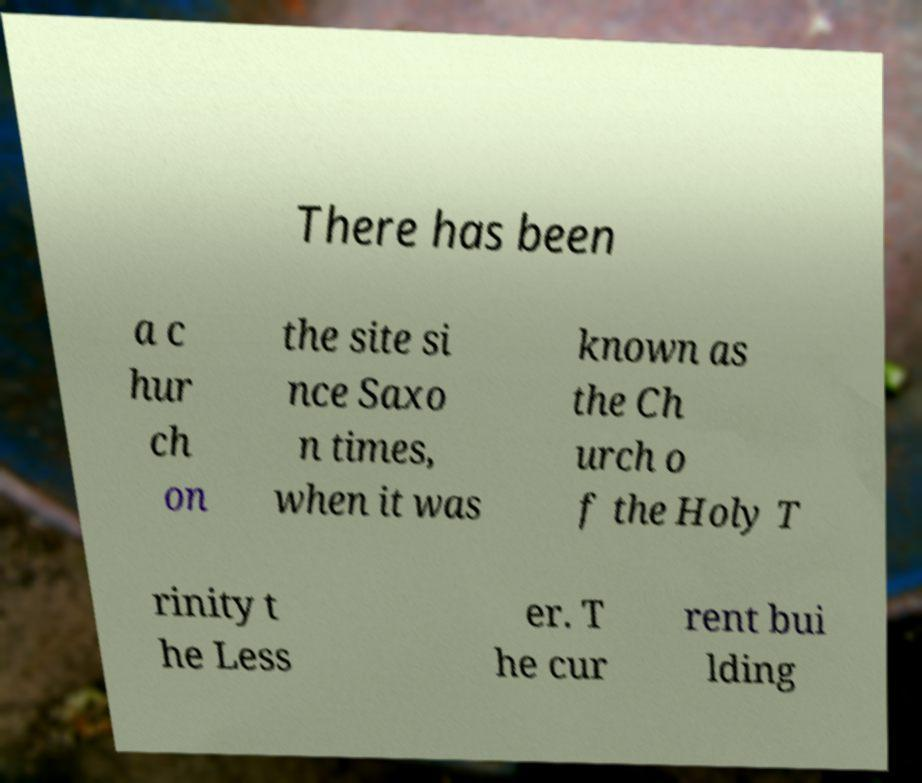Can you accurately transcribe the text from the provided image for me? There has been a c hur ch on the site si nce Saxo n times, when it was known as the Ch urch o f the Holy T rinity t he Less er. T he cur rent bui lding 